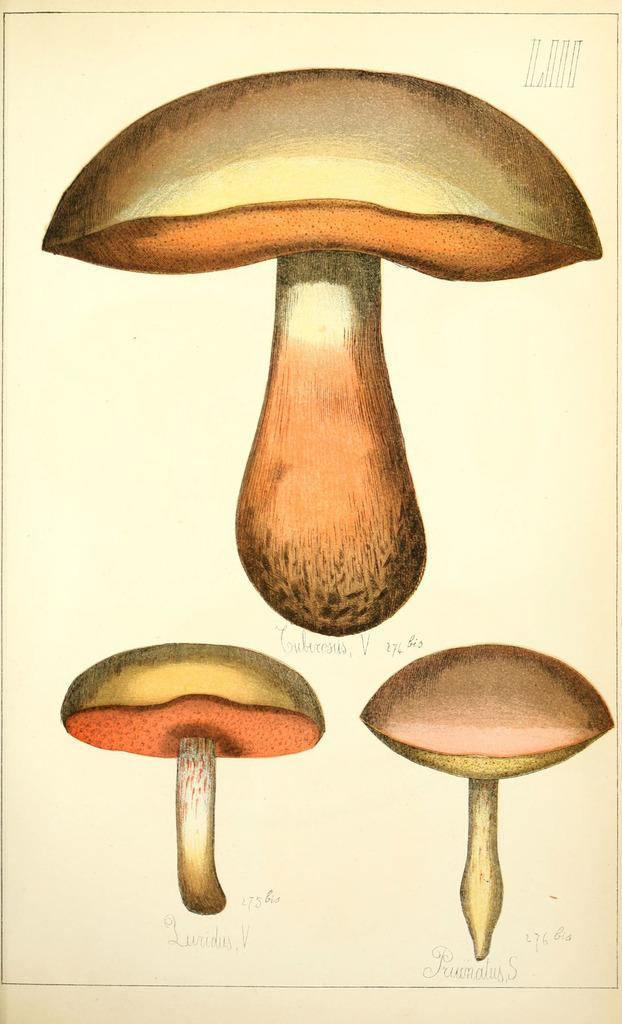What is depicted on the paper in the image? There are mushroom pictures on a paper. What else can be found on the paper besides the mushroom pictures? There is text on the paper. What type of ray is swimming in the image? There is no ray present in the image; it only features mushroom pictures and text on a paper. 